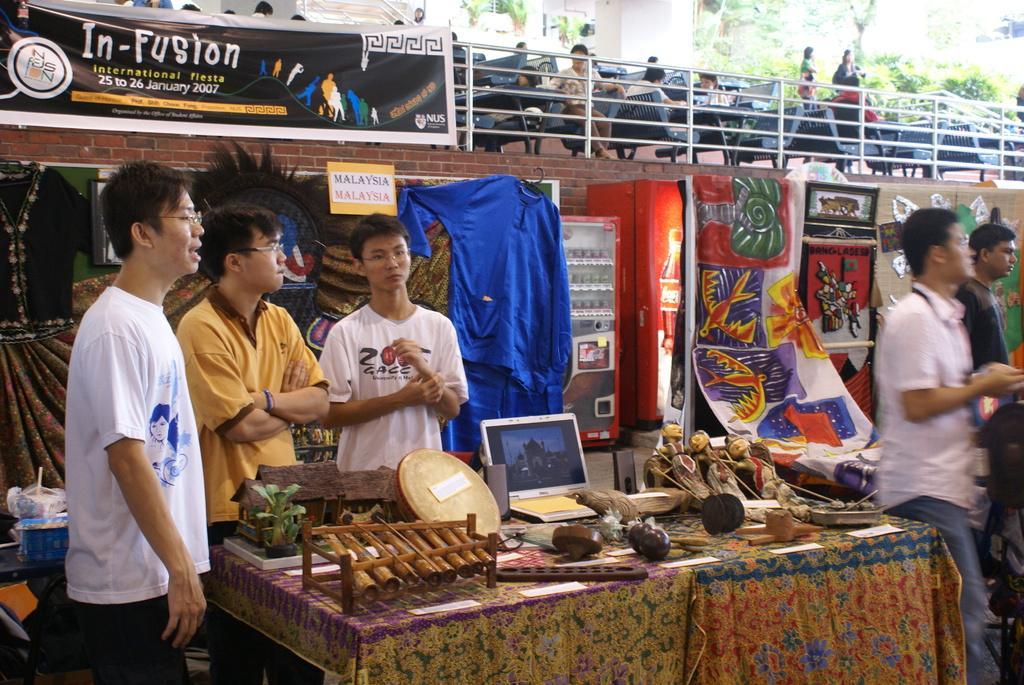Could you give a brief overview of what you see in this image? In this picture there is a table in the center of the image, which consists of different wood items and there are people on the right and left side of the image, there are posters and clothes behind them, there are other people those who are sitting on the chairs at the top side of the image and there are trees at the top side of the image. 